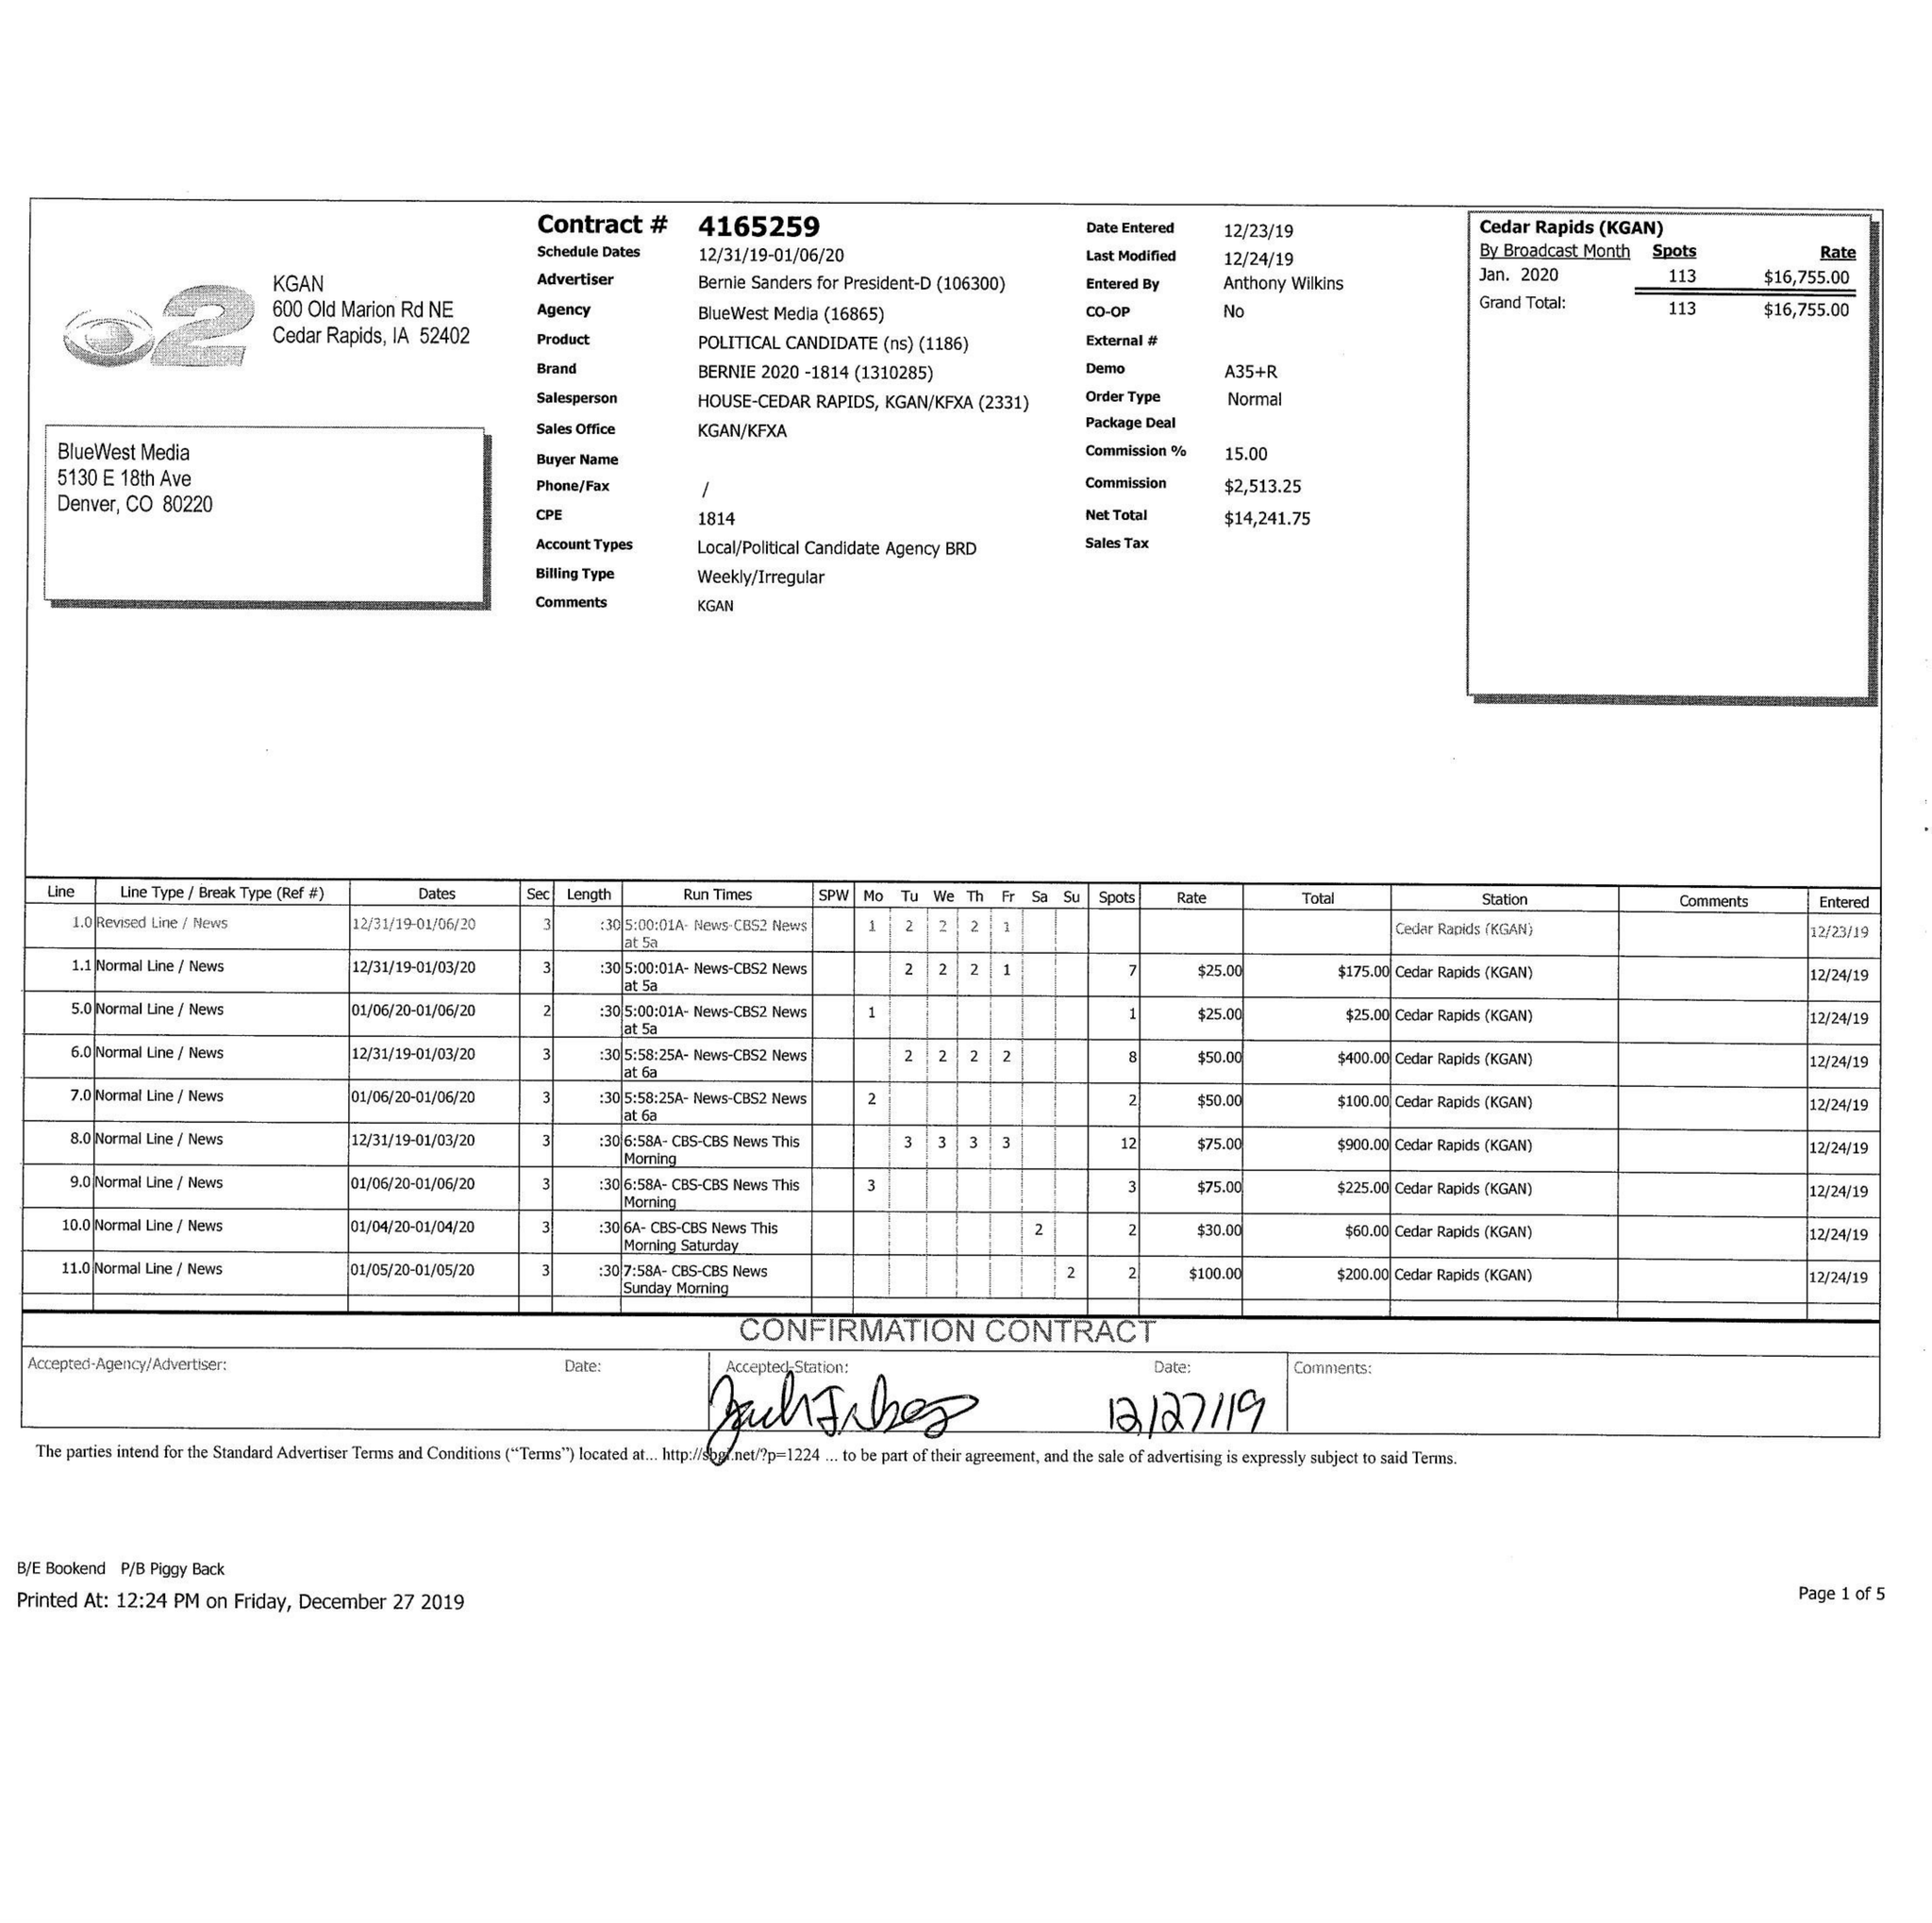What is the value for the gross_amount?
Answer the question using a single word or phrase. 16755.00 